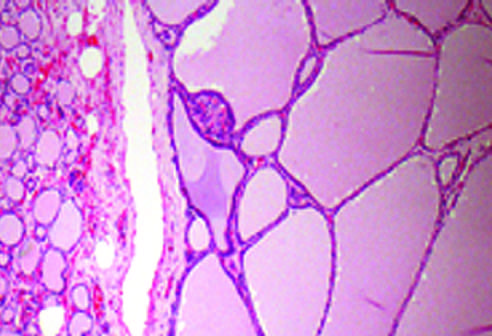what contain abundant pink colloid within their lumina?
Answer the question using a single word or phrase. The hyperplastic follicles 